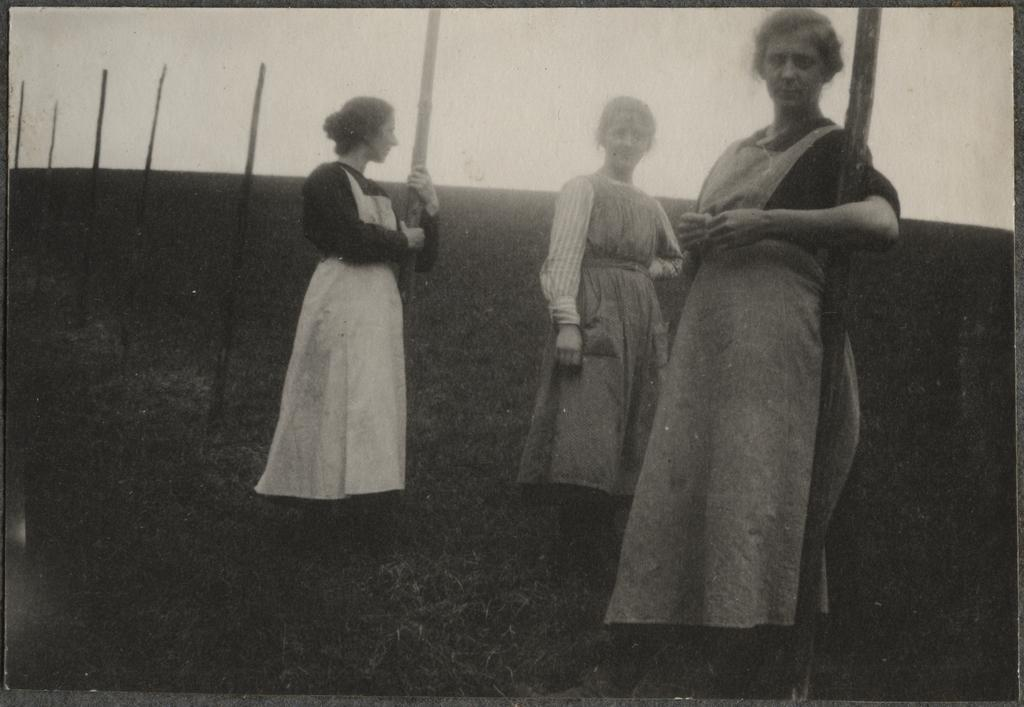How many women are in the image? There are three women in the image. What are the women wearing? The women are wearing gowns. Where are the women standing? The women are standing in a grass lawn. What are the women doing in the image? The women are looking at the camera. What can be seen in the background of the image? There are bamboo sticks in the grass ground in the background. What advice does the writer in the image give to the stranger? There is no writer or stranger present in the image; it features three women in gowns standing in a grass lawn. 